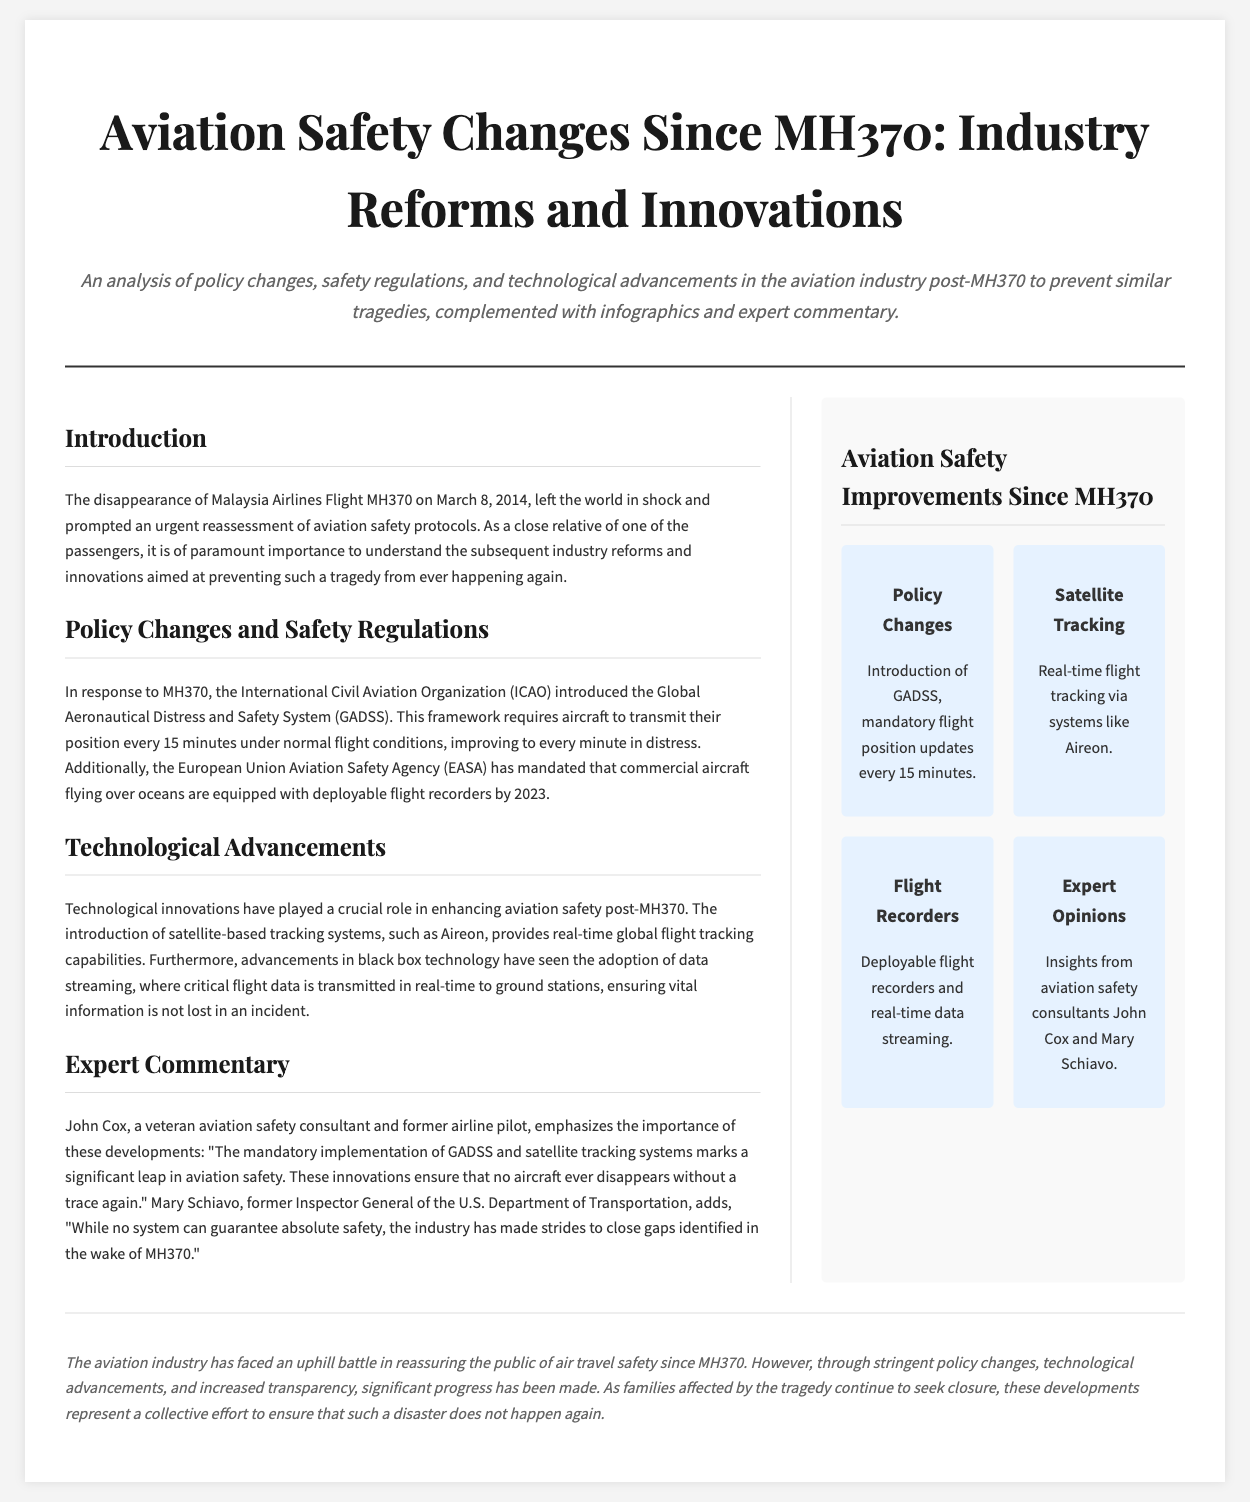What was the date of the MH370 disappearance? The document states the disappearance of Malaysia Airlines Flight MH370 occurred on March 8, 2014.
Answer: March 8, 2014 What does GADSS stand for? In the context of the document, GADSS refers to the Global Aeronautical Distress and Safety System introduced by ICAO.
Answer: Global Aeronautical Distress and Safety System How often must aircraft transmit their position under normal conditions according to GADSS? The document indicates that the GADSS requires aircraft to transmit their position every 15 minutes under normal flight conditions.
Answer: Every 15 minutes Who is John Cox? The document describes John Cox as a veteran aviation safety consultant and former airline pilot.
Answer: Veteran aviation safety consultant and former airline pilot What technological system provides real-time global flight tracking capabilities? According to the document, the Aireon system offers real-time global flight tracking capabilities.
Answer: Aireon What innovation is mandated for commercial aircraft flying over oceans by 2023? The document states that commercial aircraft flying over oceans are required to have deployable flight recorders by 2023.
Answer: Deployable flight recorders What is the main focus of the article? The document concentrates on aviation safety changes since the disappearance of MH370 and the resulting industry reforms and innovations.
Answer: Aviation safety changes since MH370 What type of opinions does the sidebar feature? The sidebar includes insights from aviation safety consultants, specifically John Cox and Mary Schiavo.
Answer: Expert Opinions 